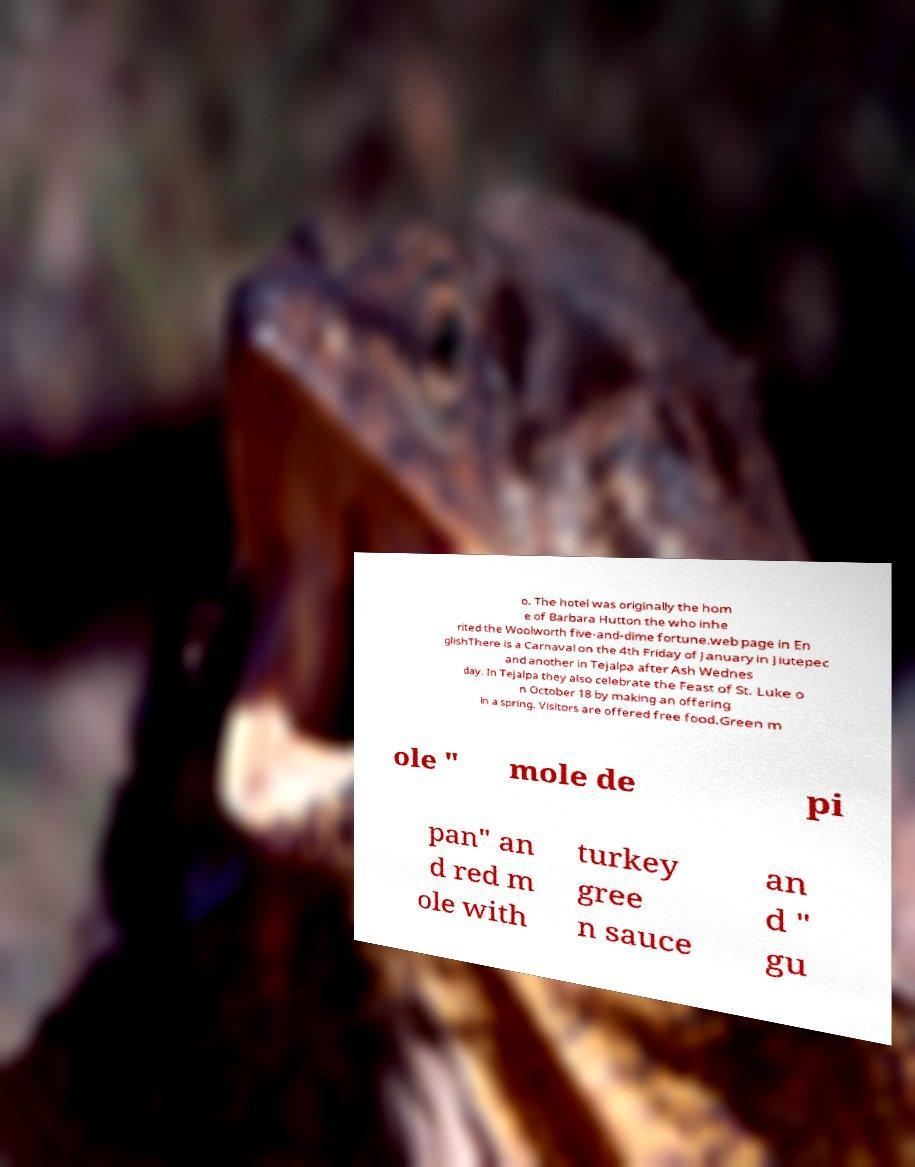Could you extract and type out the text from this image? o. The hotel was originally the hom e of Barbara Hutton the who inhe rited the Woolworth five-and-dime fortune.web page in En glishThere is a Carnaval on the 4th Friday of January in Jiutepec and another in Tejalpa after Ash Wednes day. In Tejalpa they also celebrate the Feast of St. Luke o n October 18 by making an offering in a spring. Visitors are offered free food.Green m ole " mole de pi pan" an d red m ole with turkey gree n sauce an d " gu 